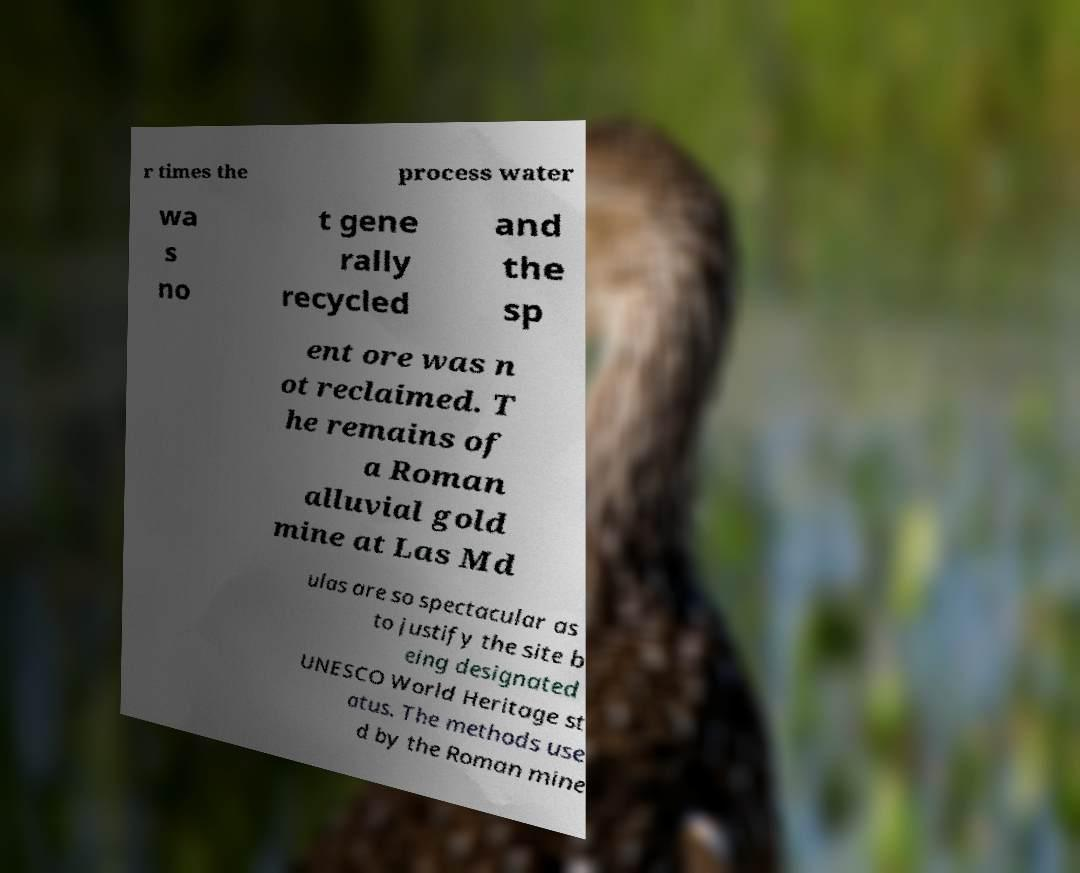Could you assist in decoding the text presented in this image and type it out clearly? r times the process water wa s no t gene rally recycled and the sp ent ore was n ot reclaimed. T he remains of a Roman alluvial gold mine at Las Md ulas are so spectacular as to justify the site b eing designated UNESCO World Heritage st atus. The methods use d by the Roman mine 